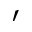<formula> <loc_0><loc_0><loc_500><loc_500>^ { \prime }</formula> 